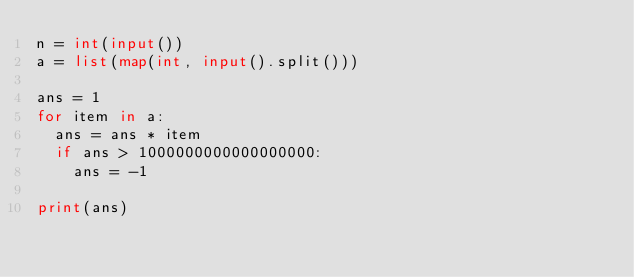Convert code to text. <code><loc_0><loc_0><loc_500><loc_500><_Python_>n = int(input())
a = list(map(int, input().split()))

ans = 1
for item in a:
  ans = ans * item
  if ans > 1000000000000000000:
    ans = -1

print(ans)
</code> 